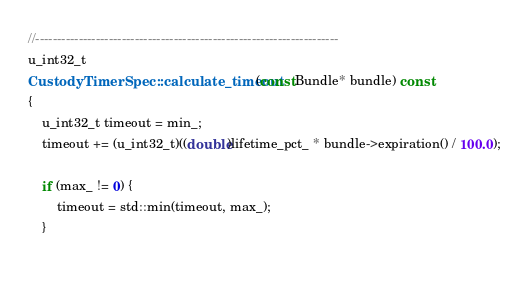<code> <loc_0><loc_0><loc_500><loc_500><_C++_>
//----------------------------------------------------------------------
u_int32_t
CustodyTimerSpec::calculate_timeout(const Bundle* bundle) const
{
    u_int32_t timeout = min_;
    timeout += (u_int32_t)((double)lifetime_pct_ * bundle->expiration() / 100.0);

    if (max_ != 0) {
        timeout = std::min(timeout, max_);
    }
    </code> 